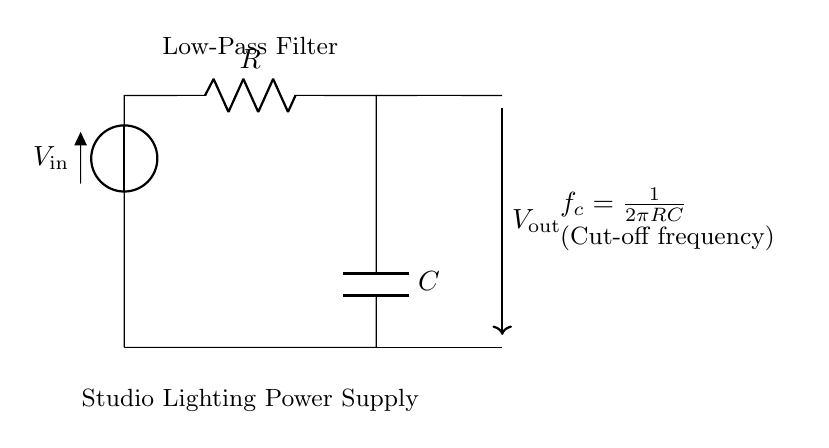What is the input voltage in the circuit? The input voltage is denoted as \( V_\text{in} \), which indicates the source providing power to the circuit.
Answer: \( V_\text{in} \) What components are present in this circuit? The circuit diagram contains two main components: a resistor labeled \( R \) and a capacitor labeled \( C \).
Answer: Resistor and Capacitor What type of filter is represented in this circuit? The circuit is labeled as a "Low-Pass Filter," indicating that it allows low-frequency signals to pass while attenuating higher frequencies.
Answer: Low-Pass Filter What is the primary purpose of the capacitor in this filter? The capacitor is used to smooth out voltage fluctuations in the circuit and helps in filtering out high-frequency noise, allowing for a steady output voltage.
Answer: Smoothing voltage How is the cut-off frequency calculated in this circuit? The cut-off frequency \( f_c \) can be calculated using the formula \( f_c = \frac{1}{2\pi RC} \), which relates the resistor and capacitor values to determine the frequency at which the filter begins to attenuate signals.
Answer: \( \frac{1}{2\pi RC} \) What would happen if the resistor value is increased? Increasing the resistor value \( R \) while keeping the capacitor \( C \) constant would lower the cut-off frequency \( f_c \), allowing even lower frequencies to pass through while further attenuating higher frequencies.
Answer: Lower cut-off frequency What is the significance of the output voltage in this setup? The output voltage \( V_\text{out} \) represents the voltage that is smoothed and filtered from the input, providing a more stable power supply for studio lighting systems.
Answer: Smoother power supply 